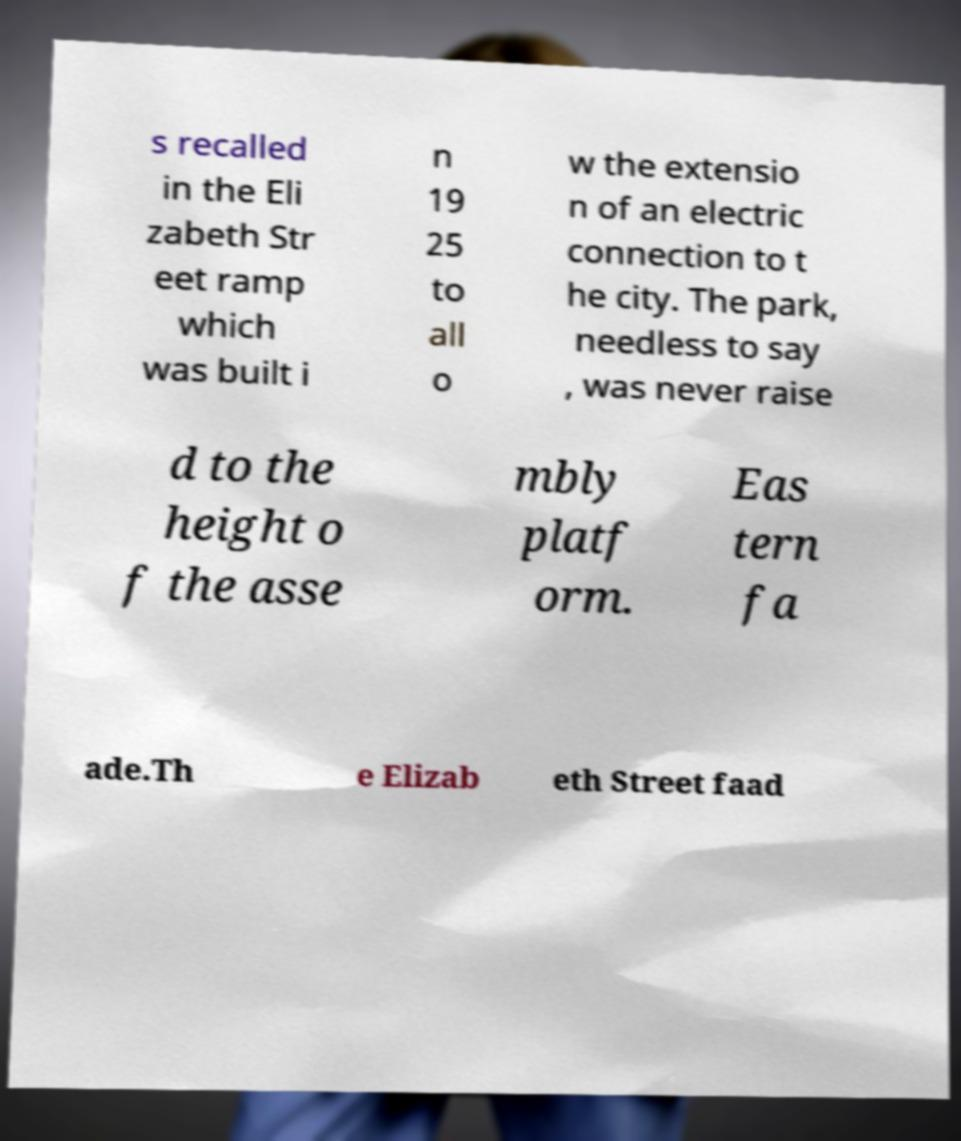Can you read and provide the text displayed in the image?This photo seems to have some interesting text. Can you extract and type it out for me? s recalled in the Eli zabeth Str eet ramp which was built i n 19 25 to all o w the extensio n of an electric connection to t he city. The park, needless to say , was never raise d to the height o f the asse mbly platf orm. Eas tern fa ade.Th e Elizab eth Street faad 